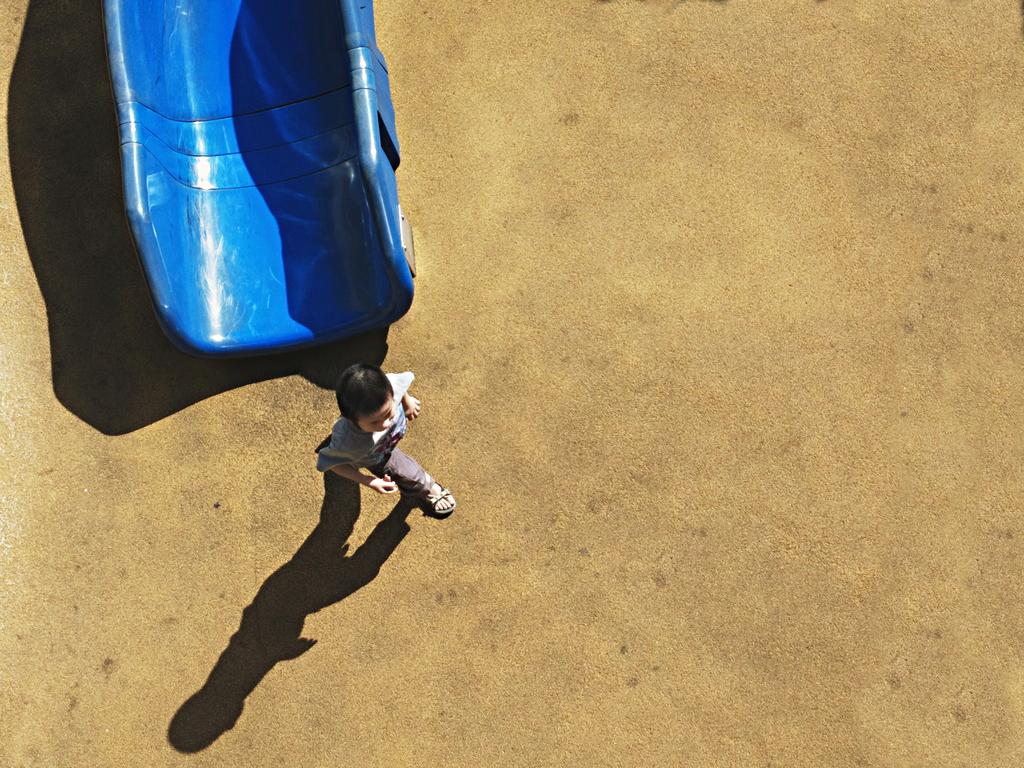What color is the object on the ground in the image? The object on the ground is blue. What is the boy in the image doing? The boy is walking in the image. Is the blue object on the ground shaking in the image? There is no indication that the blue object is shaking in the image. What type of cup is being used by the boy in the image? There is no cup present in the image; it only features a blue object on the ground and a boy walking. 